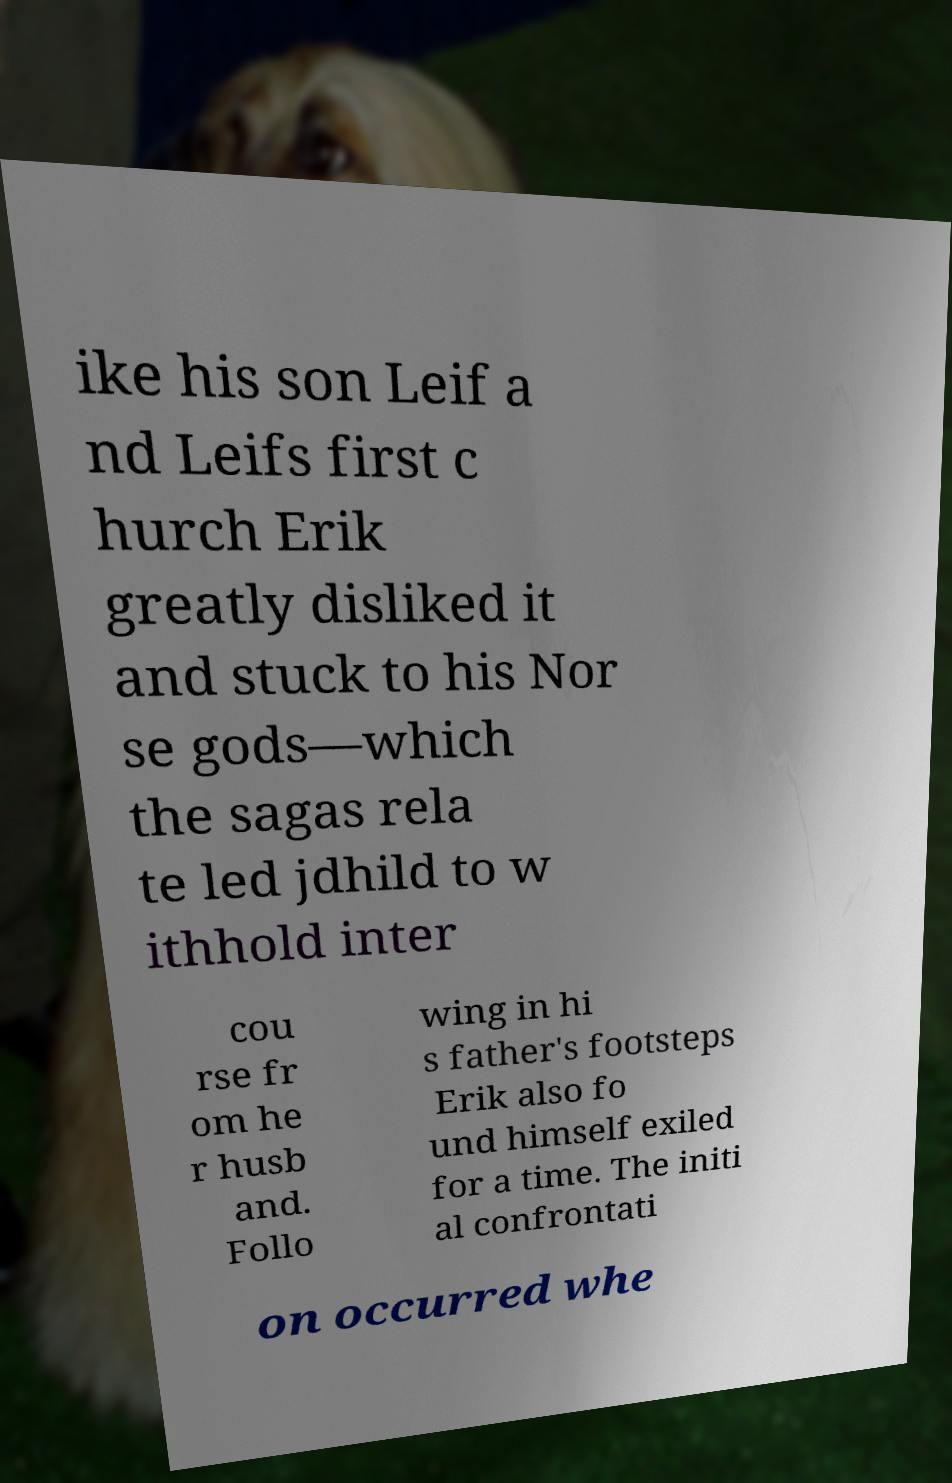For documentation purposes, I need the text within this image transcribed. Could you provide that? ike his son Leif a nd Leifs first c hurch Erik greatly disliked it and stuck to his Nor se gods—which the sagas rela te led jdhild to w ithhold inter cou rse fr om he r husb and. Follo wing in hi s father's footsteps Erik also fo und himself exiled for a time. The initi al confrontati on occurred whe 